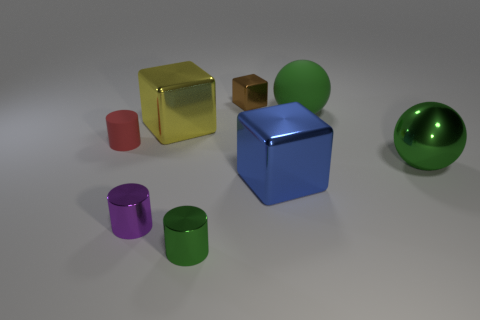Subtract 1 cylinders. How many cylinders are left? 2 Add 2 metallic blocks. How many objects exist? 10 Subtract all blocks. How many objects are left? 5 Subtract 0 brown cylinders. How many objects are left? 8 Subtract all large purple matte spheres. Subtract all spheres. How many objects are left? 6 Add 5 brown cubes. How many brown cubes are left? 6 Add 6 red objects. How many red objects exist? 7 